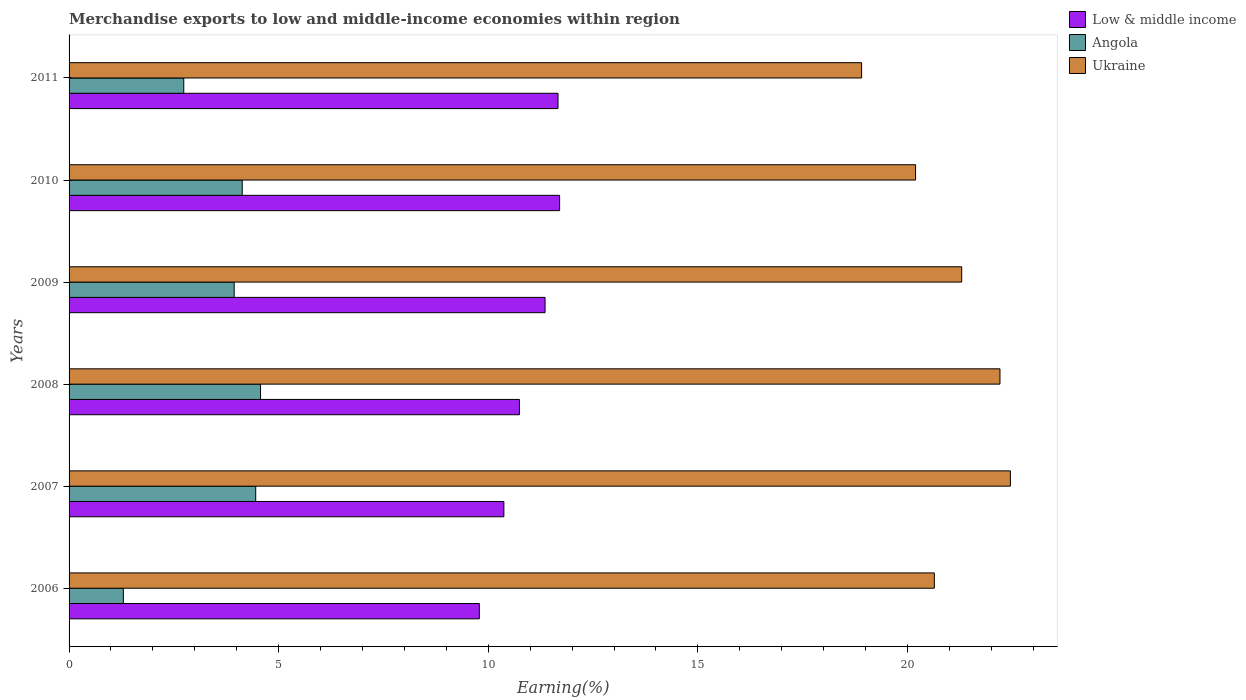How many different coloured bars are there?
Ensure brevity in your answer.  3. How many groups of bars are there?
Offer a terse response. 6. Are the number of bars per tick equal to the number of legend labels?
Your answer should be very brief. Yes. Are the number of bars on each tick of the Y-axis equal?
Offer a terse response. Yes. How many bars are there on the 3rd tick from the bottom?
Offer a very short reply. 3. In how many cases, is the number of bars for a given year not equal to the number of legend labels?
Your response must be concise. 0. What is the percentage of amount earned from merchandise exports in Low & middle income in 2006?
Your answer should be compact. 9.79. Across all years, what is the maximum percentage of amount earned from merchandise exports in Angola?
Provide a short and direct response. 4.57. Across all years, what is the minimum percentage of amount earned from merchandise exports in Angola?
Make the answer very short. 1.3. What is the total percentage of amount earned from merchandise exports in Ukraine in the graph?
Provide a succinct answer. 125.69. What is the difference between the percentage of amount earned from merchandise exports in Low & middle income in 2006 and that in 2010?
Your response must be concise. -1.91. What is the difference between the percentage of amount earned from merchandise exports in Low & middle income in 2006 and the percentage of amount earned from merchandise exports in Ukraine in 2011?
Offer a very short reply. -9.12. What is the average percentage of amount earned from merchandise exports in Angola per year?
Your answer should be very brief. 3.52. In the year 2007, what is the difference between the percentage of amount earned from merchandise exports in Angola and percentage of amount earned from merchandise exports in Ukraine?
Your answer should be compact. -18. In how many years, is the percentage of amount earned from merchandise exports in Ukraine greater than 3 %?
Offer a terse response. 6. What is the ratio of the percentage of amount earned from merchandise exports in Angola in 2006 to that in 2008?
Keep it short and to the point. 0.28. Is the percentage of amount earned from merchandise exports in Low & middle income in 2009 less than that in 2011?
Your response must be concise. Yes. Is the difference between the percentage of amount earned from merchandise exports in Angola in 2006 and 2008 greater than the difference between the percentage of amount earned from merchandise exports in Ukraine in 2006 and 2008?
Provide a short and direct response. No. What is the difference between the highest and the second highest percentage of amount earned from merchandise exports in Angola?
Keep it short and to the point. 0.11. What is the difference between the highest and the lowest percentage of amount earned from merchandise exports in Low & middle income?
Make the answer very short. 1.91. In how many years, is the percentage of amount earned from merchandise exports in Angola greater than the average percentage of amount earned from merchandise exports in Angola taken over all years?
Keep it short and to the point. 4. What does the 3rd bar from the top in 2007 represents?
Your answer should be compact. Low & middle income. What does the 2nd bar from the bottom in 2007 represents?
Offer a terse response. Angola. Is it the case that in every year, the sum of the percentage of amount earned from merchandise exports in Low & middle income and percentage of amount earned from merchandise exports in Ukraine is greater than the percentage of amount earned from merchandise exports in Angola?
Make the answer very short. Yes. How many bars are there?
Offer a very short reply. 18. How many years are there in the graph?
Your answer should be compact. 6. Are the values on the major ticks of X-axis written in scientific E-notation?
Make the answer very short. No. Does the graph contain any zero values?
Offer a terse response. No. Where does the legend appear in the graph?
Offer a terse response. Top right. How many legend labels are there?
Ensure brevity in your answer.  3. What is the title of the graph?
Your answer should be compact. Merchandise exports to low and middle-income economies within region. What is the label or title of the X-axis?
Your answer should be very brief. Earning(%). What is the label or title of the Y-axis?
Make the answer very short. Years. What is the Earning(%) of Low & middle income in 2006?
Offer a terse response. 9.79. What is the Earning(%) in Angola in 2006?
Provide a succinct answer. 1.3. What is the Earning(%) of Ukraine in 2006?
Offer a terse response. 20.64. What is the Earning(%) of Low & middle income in 2007?
Keep it short and to the point. 10.37. What is the Earning(%) in Angola in 2007?
Your response must be concise. 4.45. What is the Earning(%) in Ukraine in 2007?
Make the answer very short. 22.46. What is the Earning(%) in Low & middle income in 2008?
Ensure brevity in your answer.  10.74. What is the Earning(%) of Angola in 2008?
Keep it short and to the point. 4.57. What is the Earning(%) of Ukraine in 2008?
Make the answer very short. 22.21. What is the Earning(%) of Low & middle income in 2009?
Ensure brevity in your answer.  11.35. What is the Earning(%) of Angola in 2009?
Make the answer very short. 3.94. What is the Earning(%) of Ukraine in 2009?
Ensure brevity in your answer.  21.29. What is the Earning(%) of Low & middle income in 2010?
Give a very brief answer. 11.7. What is the Earning(%) of Angola in 2010?
Keep it short and to the point. 4.13. What is the Earning(%) of Ukraine in 2010?
Offer a terse response. 20.19. What is the Earning(%) of Low & middle income in 2011?
Your response must be concise. 11.66. What is the Earning(%) of Angola in 2011?
Keep it short and to the point. 2.74. What is the Earning(%) of Ukraine in 2011?
Provide a succinct answer. 18.91. Across all years, what is the maximum Earning(%) of Low & middle income?
Provide a succinct answer. 11.7. Across all years, what is the maximum Earning(%) of Angola?
Your answer should be very brief. 4.57. Across all years, what is the maximum Earning(%) of Ukraine?
Your response must be concise. 22.46. Across all years, what is the minimum Earning(%) in Low & middle income?
Provide a succinct answer. 9.79. Across all years, what is the minimum Earning(%) of Angola?
Offer a very short reply. 1.3. Across all years, what is the minimum Earning(%) of Ukraine?
Make the answer very short. 18.91. What is the total Earning(%) of Low & middle income in the graph?
Provide a short and direct response. 65.62. What is the total Earning(%) in Angola in the graph?
Provide a succinct answer. 21.12. What is the total Earning(%) of Ukraine in the graph?
Provide a succinct answer. 125.69. What is the difference between the Earning(%) of Low & middle income in 2006 and that in 2007?
Your answer should be compact. -0.59. What is the difference between the Earning(%) of Angola in 2006 and that in 2007?
Offer a very short reply. -3.16. What is the difference between the Earning(%) in Ukraine in 2006 and that in 2007?
Ensure brevity in your answer.  -1.81. What is the difference between the Earning(%) of Low & middle income in 2006 and that in 2008?
Your answer should be compact. -0.96. What is the difference between the Earning(%) of Angola in 2006 and that in 2008?
Ensure brevity in your answer.  -3.27. What is the difference between the Earning(%) in Ukraine in 2006 and that in 2008?
Make the answer very short. -1.57. What is the difference between the Earning(%) in Low & middle income in 2006 and that in 2009?
Keep it short and to the point. -1.57. What is the difference between the Earning(%) of Angola in 2006 and that in 2009?
Provide a succinct answer. -2.64. What is the difference between the Earning(%) in Ukraine in 2006 and that in 2009?
Give a very brief answer. -0.65. What is the difference between the Earning(%) of Low & middle income in 2006 and that in 2010?
Offer a very short reply. -1.91. What is the difference between the Earning(%) of Angola in 2006 and that in 2010?
Give a very brief answer. -2.84. What is the difference between the Earning(%) of Ukraine in 2006 and that in 2010?
Provide a short and direct response. 0.45. What is the difference between the Earning(%) in Low & middle income in 2006 and that in 2011?
Ensure brevity in your answer.  -1.88. What is the difference between the Earning(%) of Angola in 2006 and that in 2011?
Make the answer very short. -1.44. What is the difference between the Earning(%) in Ukraine in 2006 and that in 2011?
Ensure brevity in your answer.  1.74. What is the difference between the Earning(%) in Low & middle income in 2007 and that in 2008?
Provide a short and direct response. -0.37. What is the difference between the Earning(%) of Angola in 2007 and that in 2008?
Ensure brevity in your answer.  -0.11. What is the difference between the Earning(%) of Ukraine in 2007 and that in 2008?
Provide a succinct answer. 0.25. What is the difference between the Earning(%) of Low & middle income in 2007 and that in 2009?
Make the answer very short. -0.98. What is the difference between the Earning(%) in Angola in 2007 and that in 2009?
Provide a short and direct response. 0.51. What is the difference between the Earning(%) of Ukraine in 2007 and that in 2009?
Your answer should be very brief. 1.16. What is the difference between the Earning(%) in Low & middle income in 2007 and that in 2010?
Provide a short and direct response. -1.33. What is the difference between the Earning(%) in Angola in 2007 and that in 2010?
Ensure brevity in your answer.  0.32. What is the difference between the Earning(%) of Ukraine in 2007 and that in 2010?
Your answer should be very brief. 2.26. What is the difference between the Earning(%) in Low & middle income in 2007 and that in 2011?
Your response must be concise. -1.29. What is the difference between the Earning(%) of Angola in 2007 and that in 2011?
Provide a short and direct response. 1.72. What is the difference between the Earning(%) in Ukraine in 2007 and that in 2011?
Offer a very short reply. 3.55. What is the difference between the Earning(%) of Low & middle income in 2008 and that in 2009?
Your answer should be compact. -0.61. What is the difference between the Earning(%) in Angola in 2008 and that in 2009?
Your answer should be very brief. 0.63. What is the difference between the Earning(%) of Ukraine in 2008 and that in 2009?
Ensure brevity in your answer.  0.91. What is the difference between the Earning(%) in Low & middle income in 2008 and that in 2010?
Ensure brevity in your answer.  -0.96. What is the difference between the Earning(%) in Angola in 2008 and that in 2010?
Offer a very short reply. 0.44. What is the difference between the Earning(%) of Ukraine in 2008 and that in 2010?
Your answer should be very brief. 2.01. What is the difference between the Earning(%) in Low & middle income in 2008 and that in 2011?
Your answer should be very brief. -0.92. What is the difference between the Earning(%) in Angola in 2008 and that in 2011?
Offer a terse response. 1.83. What is the difference between the Earning(%) of Ukraine in 2008 and that in 2011?
Your answer should be very brief. 3.3. What is the difference between the Earning(%) in Low & middle income in 2009 and that in 2010?
Offer a terse response. -0.35. What is the difference between the Earning(%) of Angola in 2009 and that in 2010?
Offer a very short reply. -0.19. What is the difference between the Earning(%) of Ukraine in 2009 and that in 2010?
Give a very brief answer. 1.1. What is the difference between the Earning(%) in Low & middle income in 2009 and that in 2011?
Provide a succinct answer. -0.31. What is the difference between the Earning(%) in Angola in 2009 and that in 2011?
Your answer should be very brief. 1.2. What is the difference between the Earning(%) of Ukraine in 2009 and that in 2011?
Your response must be concise. 2.39. What is the difference between the Earning(%) of Low & middle income in 2010 and that in 2011?
Provide a short and direct response. 0.04. What is the difference between the Earning(%) of Angola in 2010 and that in 2011?
Your answer should be very brief. 1.39. What is the difference between the Earning(%) in Ukraine in 2010 and that in 2011?
Make the answer very short. 1.29. What is the difference between the Earning(%) of Low & middle income in 2006 and the Earning(%) of Angola in 2007?
Keep it short and to the point. 5.33. What is the difference between the Earning(%) of Low & middle income in 2006 and the Earning(%) of Ukraine in 2007?
Keep it short and to the point. -12.67. What is the difference between the Earning(%) in Angola in 2006 and the Earning(%) in Ukraine in 2007?
Keep it short and to the point. -21.16. What is the difference between the Earning(%) in Low & middle income in 2006 and the Earning(%) in Angola in 2008?
Keep it short and to the point. 5.22. What is the difference between the Earning(%) in Low & middle income in 2006 and the Earning(%) in Ukraine in 2008?
Your response must be concise. -12.42. What is the difference between the Earning(%) of Angola in 2006 and the Earning(%) of Ukraine in 2008?
Your response must be concise. -20.91. What is the difference between the Earning(%) of Low & middle income in 2006 and the Earning(%) of Angola in 2009?
Make the answer very short. 5.85. What is the difference between the Earning(%) of Low & middle income in 2006 and the Earning(%) of Ukraine in 2009?
Your response must be concise. -11.51. What is the difference between the Earning(%) in Angola in 2006 and the Earning(%) in Ukraine in 2009?
Make the answer very short. -20. What is the difference between the Earning(%) in Low & middle income in 2006 and the Earning(%) in Angola in 2010?
Give a very brief answer. 5.66. What is the difference between the Earning(%) of Low & middle income in 2006 and the Earning(%) of Ukraine in 2010?
Offer a very short reply. -10.41. What is the difference between the Earning(%) in Angola in 2006 and the Earning(%) in Ukraine in 2010?
Make the answer very short. -18.9. What is the difference between the Earning(%) in Low & middle income in 2006 and the Earning(%) in Angola in 2011?
Provide a short and direct response. 7.05. What is the difference between the Earning(%) of Low & middle income in 2006 and the Earning(%) of Ukraine in 2011?
Offer a terse response. -9.12. What is the difference between the Earning(%) of Angola in 2006 and the Earning(%) of Ukraine in 2011?
Provide a short and direct response. -17.61. What is the difference between the Earning(%) in Low & middle income in 2007 and the Earning(%) in Angola in 2008?
Your answer should be very brief. 5.8. What is the difference between the Earning(%) in Low & middle income in 2007 and the Earning(%) in Ukraine in 2008?
Offer a terse response. -11.83. What is the difference between the Earning(%) of Angola in 2007 and the Earning(%) of Ukraine in 2008?
Your answer should be compact. -17.75. What is the difference between the Earning(%) of Low & middle income in 2007 and the Earning(%) of Angola in 2009?
Make the answer very short. 6.43. What is the difference between the Earning(%) of Low & middle income in 2007 and the Earning(%) of Ukraine in 2009?
Offer a terse response. -10.92. What is the difference between the Earning(%) in Angola in 2007 and the Earning(%) in Ukraine in 2009?
Offer a terse response. -16.84. What is the difference between the Earning(%) of Low & middle income in 2007 and the Earning(%) of Angola in 2010?
Ensure brevity in your answer.  6.24. What is the difference between the Earning(%) in Low & middle income in 2007 and the Earning(%) in Ukraine in 2010?
Your answer should be compact. -9.82. What is the difference between the Earning(%) in Angola in 2007 and the Earning(%) in Ukraine in 2010?
Offer a terse response. -15.74. What is the difference between the Earning(%) of Low & middle income in 2007 and the Earning(%) of Angola in 2011?
Make the answer very short. 7.64. What is the difference between the Earning(%) in Low & middle income in 2007 and the Earning(%) in Ukraine in 2011?
Give a very brief answer. -8.53. What is the difference between the Earning(%) of Angola in 2007 and the Earning(%) of Ukraine in 2011?
Your answer should be compact. -14.45. What is the difference between the Earning(%) in Low & middle income in 2008 and the Earning(%) in Angola in 2009?
Offer a very short reply. 6.81. What is the difference between the Earning(%) of Low & middle income in 2008 and the Earning(%) of Ukraine in 2009?
Your answer should be very brief. -10.55. What is the difference between the Earning(%) of Angola in 2008 and the Earning(%) of Ukraine in 2009?
Give a very brief answer. -16.73. What is the difference between the Earning(%) in Low & middle income in 2008 and the Earning(%) in Angola in 2010?
Offer a terse response. 6.61. What is the difference between the Earning(%) in Low & middle income in 2008 and the Earning(%) in Ukraine in 2010?
Provide a short and direct response. -9.45. What is the difference between the Earning(%) in Angola in 2008 and the Earning(%) in Ukraine in 2010?
Make the answer very short. -15.63. What is the difference between the Earning(%) of Low & middle income in 2008 and the Earning(%) of Angola in 2011?
Give a very brief answer. 8.01. What is the difference between the Earning(%) of Low & middle income in 2008 and the Earning(%) of Ukraine in 2011?
Your answer should be very brief. -8.16. What is the difference between the Earning(%) in Angola in 2008 and the Earning(%) in Ukraine in 2011?
Your response must be concise. -14.34. What is the difference between the Earning(%) in Low & middle income in 2009 and the Earning(%) in Angola in 2010?
Provide a succinct answer. 7.22. What is the difference between the Earning(%) of Low & middle income in 2009 and the Earning(%) of Ukraine in 2010?
Keep it short and to the point. -8.84. What is the difference between the Earning(%) of Angola in 2009 and the Earning(%) of Ukraine in 2010?
Offer a terse response. -16.25. What is the difference between the Earning(%) of Low & middle income in 2009 and the Earning(%) of Angola in 2011?
Your answer should be very brief. 8.62. What is the difference between the Earning(%) of Low & middle income in 2009 and the Earning(%) of Ukraine in 2011?
Your answer should be compact. -7.55. What is the difference between the Earning(%) of Angola in 2009 and the Earning(%) of Ukraine in 2011?
Provide a succinct answer. -14.97. What is the difference between the Earning(%) in Low & middle income in 2010 and the Earning(%) in Angola in 2011?
Keep it short and to the point. 8.97. What is the difference between the Earning(%) in Low & middle income in 2010 and the Earning(%) in Ukraine in 2011?
Your response must be concise. -7.2. What is the difference between the Earning(%) in Angola in 2010 and the Earning(%) in Ukraine in 2011?
Give a very brief answer. -14.77. What is the average Earning(%) of Low & middle income per year?
Give a very brief answer. 10.94. What is the average Earning(%) in Angola per year?
Offer a very short reply. 3.52. What is the average Earning(%) in Ukraine per year?
Offer a terse response. 20.95. In the year 2006, what is the difference between the Earning(%) in Low & middle income and Earning(%) in Angola?
Offer a terse response. 8.49. In the year 2006, what is the difference between the Earning(%) of Low & middle income and Earning(%) of Ukraine?
Your response must be concise. -10.85. In the year 2006, what is the difference between the Earning(%) of Angola and Earning(%) of Ukraine?
Make the answer very short. -19.35. In the year 2007, what is the difference between the Earning(%) of Low & middle income and Earning(%) of Angola?
Ensure brevity in your answer.  5.92. In the year 2007, what is the difference between the Earning(%) of Low & middle income and Earning(%) of Ukraine?
Your response must be concise. -12.08. In the year 2007, what is the difference between the Earning(%) of Angola and Earning(%) of Ukraine?
Offer a terse response. -18. In the year 2008, what is the difference between the Earning(%) in Low & middle income and Earning(%) in Angola?
Give a very brief answer. 6.18. In the year 2008, what is the difference between the Earning(%) in Low & middle income and Earning(%) in Ukraine?
Give a very brief answer. -11.46. In the year 2008, what is the difference between the Earning(%) of Angola and Earning(%) of Ukraine?
Offer a very short reply. -17.64. In the year 2009, what is the difference between the Earning(%) of Low & middle income and Earning(%) of Angola?
Provide a succinct answer. 7.42. In the year 2009, what is the difference between the Earning(%) of Low & middle income and Earning(%) of Ukraine?
Your answer should be very brief. -9.94. In the year 2009, what is the difference between the Earning(%) of Angola and Earning(%) of Ukraine?
Keep it short and to the point. -17.36. In the year 2010, what is the difference between the Earning(%) of Low & middle income and Earning(%) of Angola?
Make the answer very short. 7.57. In the year 2010, what is the difference between the Earning(%) in Low & middle income and Earning(%) in Ukraine?
Offer a terse response. -8.49. In the year 2010, what is the difference between the Earning(%) in Angola and Earning(%) in Ukraine?
Give a very brief answer. -16.06. In the year 2011, what is the difference between the Earning(%) in Low & middle income and Earning(%) in Angola?
Your answer should be very brief. 8.93. In the year 2011, what is the difference between the Earning(%) of Low & middle income and Earning(%) of Ukraine?
Your answer should be compact. -7.24. In the year 2011, what is the difference between the Earning(%) in Angola and Earning(%) in Ukraine?
Your answer should be compact. -16.17. What is the ratio of the Earning(%) of Low & middle income in 2006 to that in 2007?
Give a very brief answer. 0.94. What is the ratio of the Earning(%) of Angola in 2006 to that in 2007?
Ensure brevity in your answer.  0.29. What is the ratio of the Earning(%) of Ukraine in 2006 to that in 2007?
Make the answer very short. 0.92. What is the ratio of the Earning(%) of Low & middle income in 2006 to that in 2008?
Make the answer very short. 0.91. What is the ratio of the Earning(%) of Angola in 2006 to that in 2008?
Your answer should be very brief. 0.28. What is the ratio of the Earning(%) of Ukraine in 2006 to that in 2008?
Your answer should be compact. 0.93. What is the ratio of the Earning(%) in Low & middle income in 2006 to that in 2009?
Provide a succinct answer. 0.86. What is the ratio of the Earning(%) in Angola in 2006 to that in 2009?
Provide a short and direct response. 0.33. What is the ratio of the Earning(%) in Ukraine in 2006 to that in 2009?
Provide a short and direct response. 0.97. What is the ratio of the Earning(%) of Low & middle income in 2006 to that in 2010?
Your answer should be very brief. 0.84. What is the ratio of the Earning(%) of Angola in 2006 to that in 2010?
Provide a short and direct response. 0.31. What is the ratio of the Earning(%) in Ukraine in 2006 to that in 2010?
Provide a short and direct response. 1.02. What is the ratio of the Earning(%) in Low & middle income in 2006 to that in 2011?
Give a very brief answer. 0.84. What is the ratio of the Earning(%) of Angola in 2006 to that in 2011?
Make the answer very short. 0.47. What is the ratio of the Earning(%) in Ukraine in 2006 to that in 2011?
Keep it short and to the point. 1.09. What is the ratio of the Earning(%) in Low & middle income in 2007 to that in 2008?
Make the answer very short. 0.97. What is the ratio of the Earning(%) in Angola in 2007 to that in 2008?
Offer a very short reply. 0.97. What is the ratio of the Earning(%) of Ukraine in 2007 to that in 2008?
Keep it short and to the point. 1.01. What is the ratio of the Earning(%) of Low & middle income in 2007 to that in 2009?
Your answer should be compact. 0.91. What is the ratio of the Earning(%) of Angola in 2007 to that in 2009?
Provide a short and direct response. 1.13. What is the ratio of the Earning(%) in Ukraine in 2007 to that in 2009?
Provide a short and direct response. 1.05. What is the ratio of the Earning(%) of Low & middle income in 2007 to that in 2010?
Offer a very short reply. 0.89. What is the ratio of the Earning(%) of Angola in 2007 to that in 2010?
Ensure brevity in your answer.  1.08. What is the ratio of the Earning(%) in Ukraine in 2007 to that in 2010?
Provide a succinct answer. 1.11. What is the ratio of the Earning(%) of Low & middle income in 2007 to that in 2011?
Your answer should be compact. 0.89. What is the ratio of the Earning(%) in Angola in 2007 to that in 2011?
Your answer should be compact. 1.63. What is the ratio of the Earning(%) of Ukraine in 2007 to that in 2011?
Offer a very short reply. 1.19. What is the ratio of the Earning(%) of Low & middle income in 2008 to that in 2009?
Provide a short and direct response. 0.95. What is the ratio of the Earning(%) of Angola in 2008 to that in 2009?
Give a very brief answer. 1.16. What is the ratio of the Earning(%) of Ukraine in 2008 to that in 2009?
Ensure brevity in your answer.  1.04. What is the ratio of the Earning(%) of Low & middle income in 2008 to that in 2010?
Offer a very short reply. 0.92. What is the ratio of the Earning(%) in Angola in 2008 to that in 2010?
Offer a terse response. 1.11. What is the ratio of the Earning(%) in Ukraine in 2008 to that in 2010?
Your response must be concise. 1.1. What is the ratio of the Earning(%) of Low & middle income in 2008 to that in 2011?
Offer a very short reply. 0.92. What is the ratio of the Earning(%) in Angola in 2008 to that in 2011?
Keep it short and to the point. 1.67. What is the ratio of the Earning(%) of Ukraine in 2008 to that in 2011?
Ensure brevity in your answer.  1.17. What is the ratio of the Earning(%) in Low & middle income in 2009 to that in 2010?
Provide a succinct answer. 0.97. What is the ratio of the Earning(%) of Angola in 2009 to that in 2010?
Offer a terse response. 0.95. What is the ratio of the Earning(%) in Ukraine in 2009 to that in 2010?
Ensure brevity in your answer.  1.05. What is the ratio of the Earning(%) in Low & middle income in 2009 to that in 2011?
Your response must be concise. 0.97. What is the ratio of the Earning(%) of Angola in 2009 to that in 2011?
Make the answer very short. 1.44. What is the ratio of the Earning(%) in Ukraine in 2009 to that in 2011?
Offer a very short reply. 1.13. What is the ratio of the Earning(%) of Angola in 2010 to that in 2011?
Provide a succinct answer. 1.51. What is the ratio of the Earning(%) in Ukraine in 2010 to that in 2011?
Your response must be concise. 1.07. What is the difference between the highest and the second highest Earning(%) of Low & middle income?
Your answer should be very brief. 0.04. What is the difference between the highest and the second highest Earning(%) in Angola?
Your answer should be compact. 0.11. What is the difference between the highest and the second highest Earning(%) in Ukraine?
Your response must be concise. 0.25. What is the difference between the highest and the lowest Earning(%) of Low & middle income?
Provide a succinct answer. 1.91. What is the difference between the highest and the lowest Earning(%) in Angola?
Make the answer very short. 3.27. What is the difference between the highest and the lowest Earning(%) in Ukraine?
Offer a terse response. 3.55. 